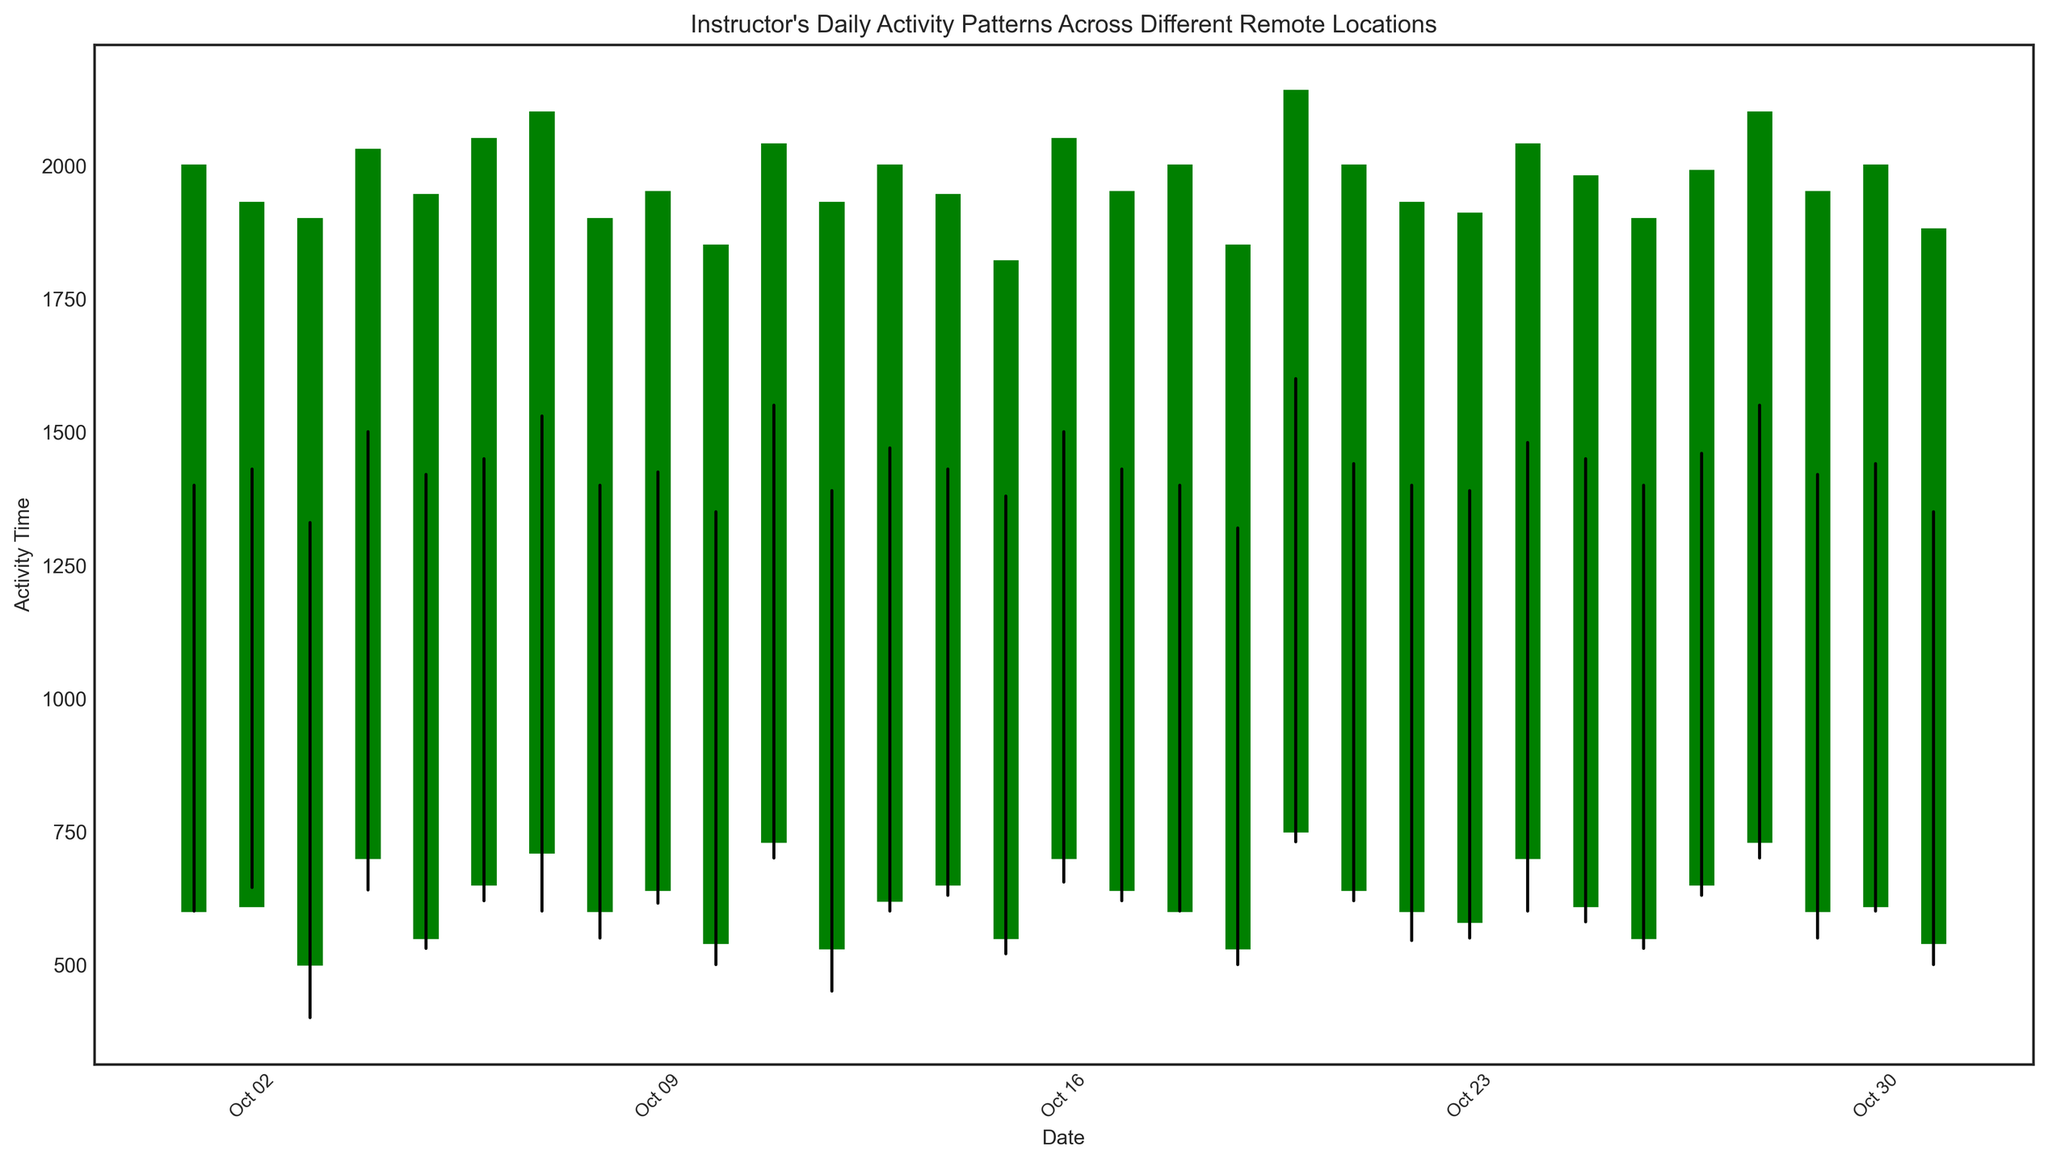What is the average closing time for the instructor across all days? To find the average closing time, sum up all the 'Close' values and then divide by the number of days. The sum is 61070 (2000 + 1930 + 1900 + 2030 + 1945 + 2050 + 2100 + 1900 + 1950 + 1850 + 2040 + 1930 + 2000 + 1945 + 1820 + 2050 + 1950 + 2000 + 1850 + 2140 + 2000 + 1930 + 1910 + 2040 + 1980 + 1900 + 1990 + 2100 + 1950 + 2000 + 1880), and there are 31 days. The average can be calculated as 61070 / 31 ≈ 1969.03
Answer: 1969 Which day shows the largest range between high and low activity times? The range between high and low activity times is calculated by subtracting the 'Low' value from the 'High' value for each day. The largest range will have the highest difference. The largest range is 870 (1600 - 730) on 2023-10-20.
Answer: 2023-10-20 On which day did the instructor have the latest closing time? Examine the 'Close' values for all days and identify the highest value, which is the latest closing time. The latest closing time is 2140 on 2023-10-20.
Answer: 2023-10-20 Which day had the earliest starting (open) activity time? Examine the 'Open' values for all days and identify the lowest value, which is the earliest starting time. The earliest starting time is 530 on 2023-10-12 and 2023-10-19.
Answer: 2023-10-12, 2023-10-19 How many days did the instructor's activity time end later than it began (i.e., the closing time is higher than the opening time)? Count the instances where the value of 'Close' is greater than the value of 'Open'. There are 19 such days.
Answer: 19 What is the difference in total activity time between the days with the highest and lowest closing times? Identify the highest and lowest closing times, which are 2140 (2023-10-20) and 1820 (2023-10-15). The difference is 2140 - 1820 = 320.
Answer: 320 Which color appears more frequently on the plot: green or red? Count the number of days when the closing value is higher than or equal to the opening value (green), and the number of days when the closing value is less than the opening value (red). Green appears 19 times and red appears 12 times.
Answer: Green On which day was the instructor’s activity range the smallest? Calculate the range between high and low activity times for each day. The smallest range will have the smallest difference. The smallest range is 710 (1350 - 640) on 2023-10-31.
Answer: 2023-10-31 Which week had the highest average closing time? Divide the data into weeks and calculate the average closing time for each week. Week 3 (2023-10-15 to 2023-10-21) had the highest average closing time of 2000.
Answer: Week 3 Is there a general trend in the instructor's activity times over the month? Visually examine the plot for any upward or downward trends. While there are fluctuations, there appears to be an overall trend of increasingly later activity closing times towards the end of the month.
Answer: Increasing trend towards later closing times 